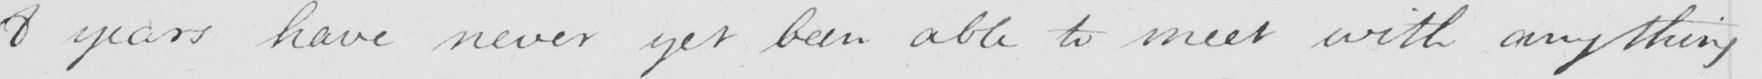What is written in this line of handwriting? 8 years have never yet been able to meet with anything 